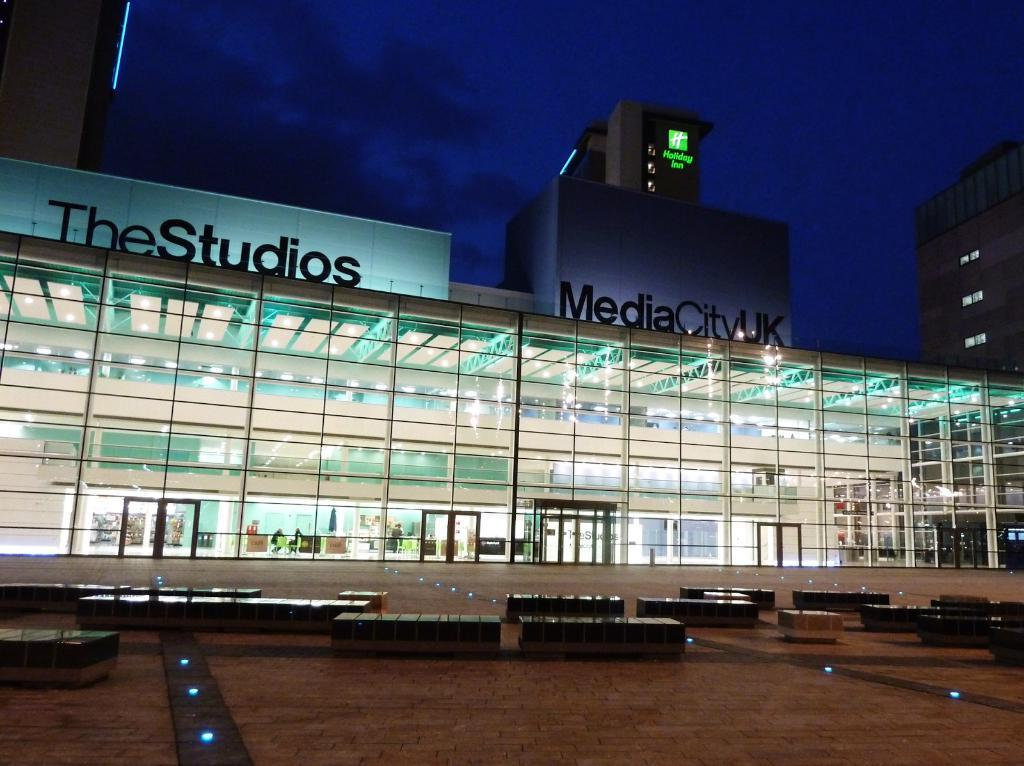What type of structures are present in the image? There are two glass buildings in the image. What feature do the glass buildings have? The buildings have windows. What is the color of the board in the image? There is a blue color board in the image. What type of seating is available in the image? There are benches in the image. What is the color of the sky in the image? The sky is blue and black in color. How much sugar is needed to sweeten the buildings in the image? There is no sugar present in the image, as the buildings are made of glass and not a consumable product. 